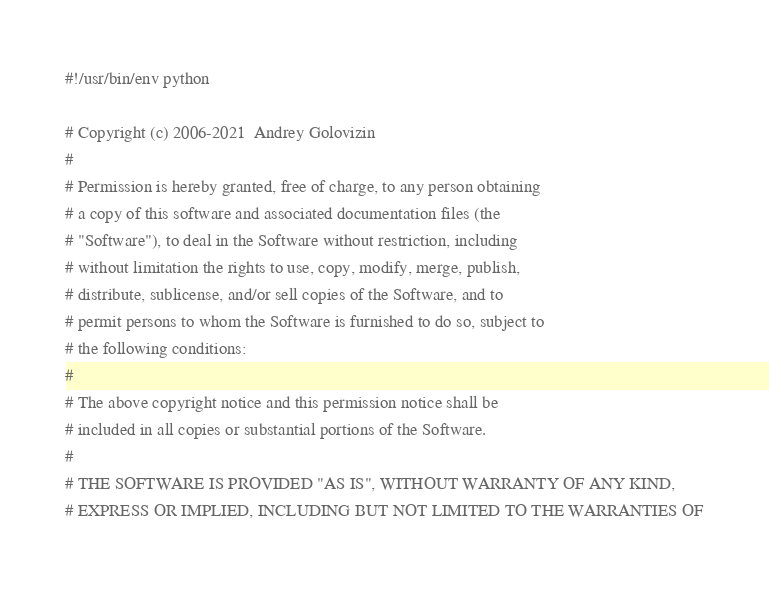Convert code to text. <code><loc_0><loc_0><loc_500><loc_500><_Python_>#!/usr/bin/env python

# Copyright (c) 2006-2021  Andrey Golovizin
#
# Permission is hereby granted, free of charge, to any person obtaining
# a copy of this software and associated documentation files (the
# "Software"), to deal in the Software without restriction, including
# without limitation the rights to use, copy, modify, merge, publish,
# distribute, sublicense, and/or sell copies of the Software, and to
# permit persons to whom the Software is furnished to do so, subject to
# the following conditions:
#
# The above copyright notice and this permission notice shall be
# included in all copies or substantial portions of the Software.
#
# THE SOFTWARE IS PROVIDED "AS IS", WITHOUT WARRANTY OF ANY KIND,
# EXPRESS OR IMPLIED, INCLUDING BUT NOT LIMITED TO THE WARRANTIES OF</code> 